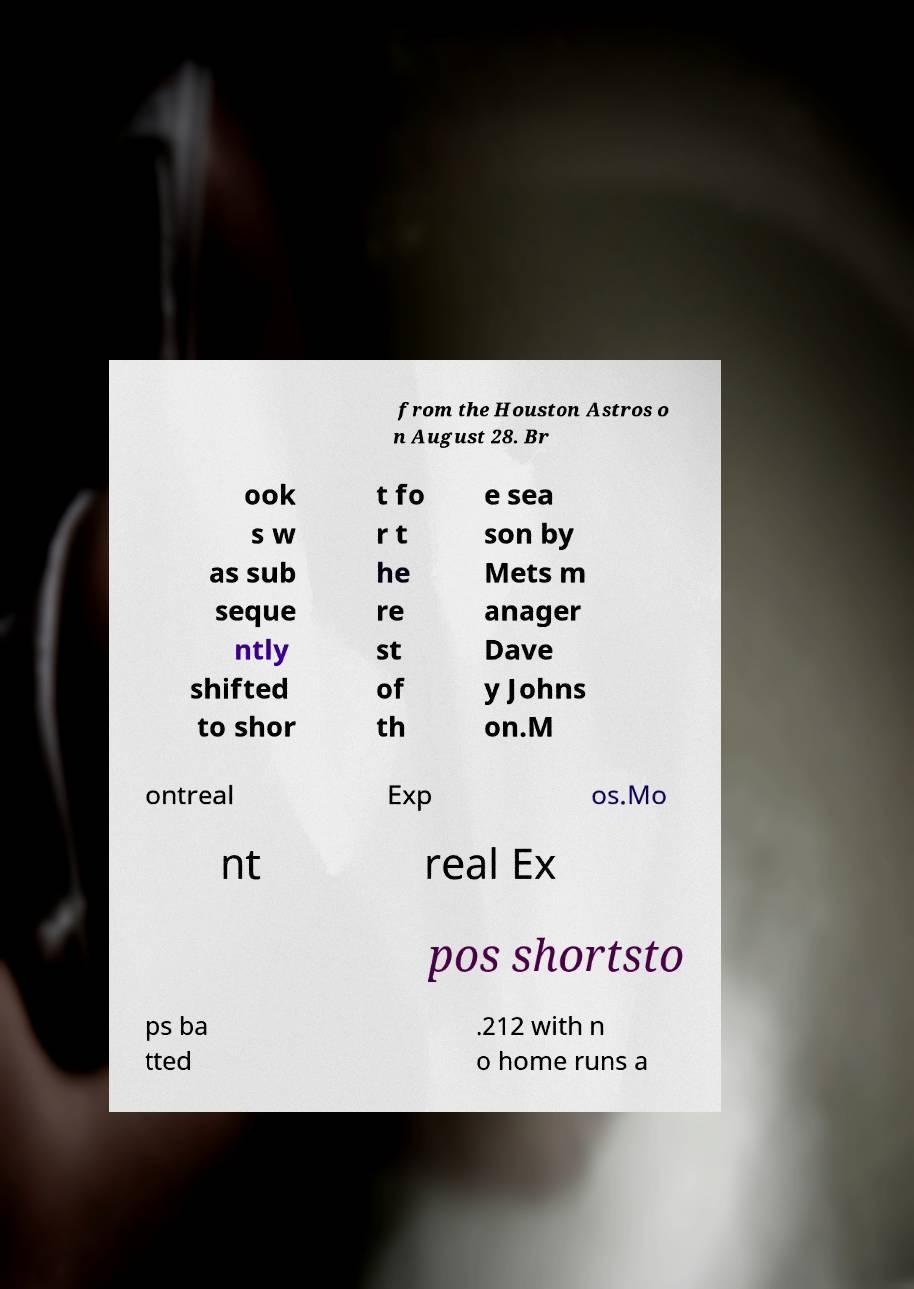For documentation purposes, I need the text within this image transcribed. Could you provide that? from the Houston Astros o n August 28. Br ook s w as sub seque ntly shifted to shor t fo r t he re st of th e sea son by Mets m anager Dave y Johns on.M ontreal Exp os.Mo nt real Ex pos shortsto ps ba tted .212 with n o home runs a 